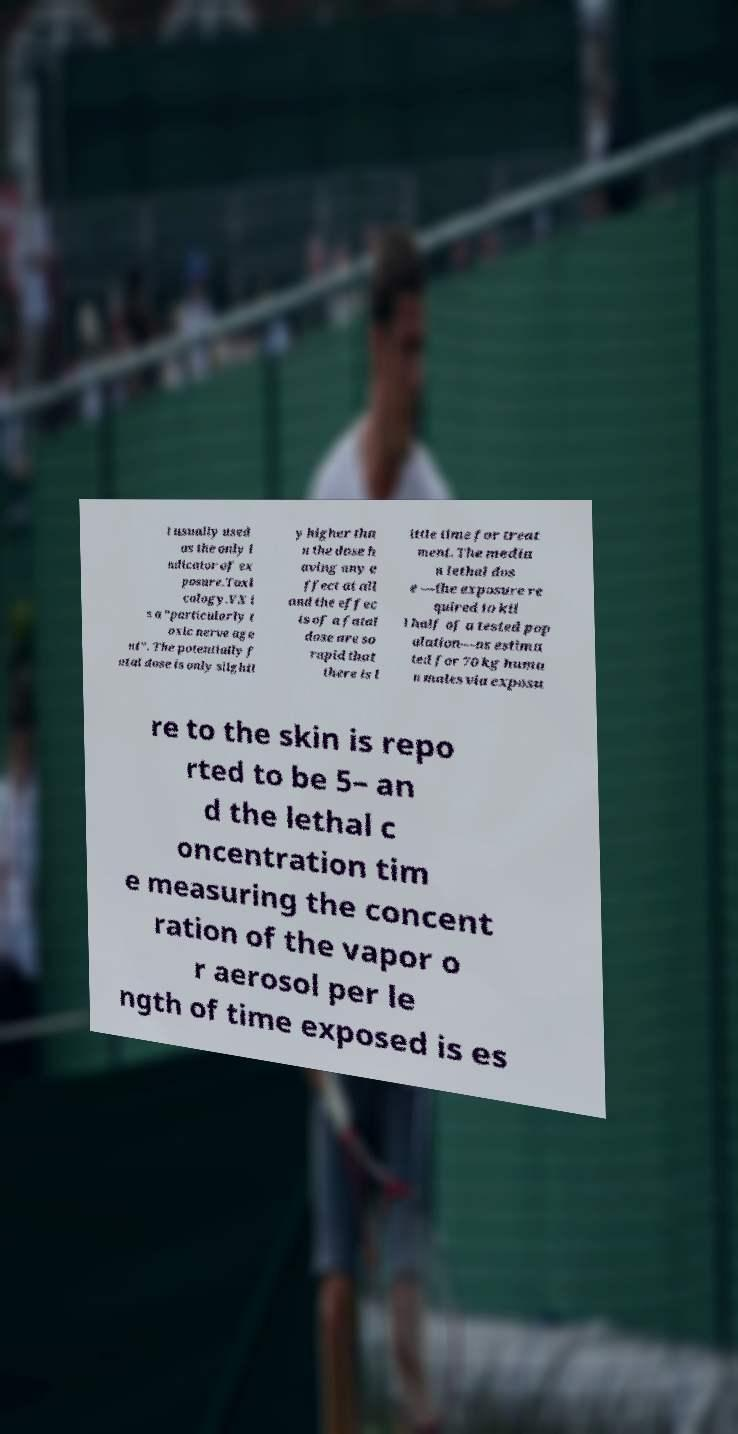Can you read and provide the text displayed in the image?This photo seems to have some interesting text. Can you extract and type it out for me? t usually used as the only i ndicator of ex posure.Toxi cology.VX i s a "particularly t oxic nerve age nt". The potentially f atal dose is only slightl y higher tha n the dose h aving any e ffect at all and the effec ts of a fatal dose are so rapid that there is l ittle time for treat ment. The media n lethal dos e —the exposure re quired to kil l half of a tested pop ulation—as estima ted for 70 kg huma n males via exposu re to the skin is repo rted to be 5– an d the lethal c oncentration tim e measuring the concent ration of the vapor o r aerosol per le ngth of time exposed is es 